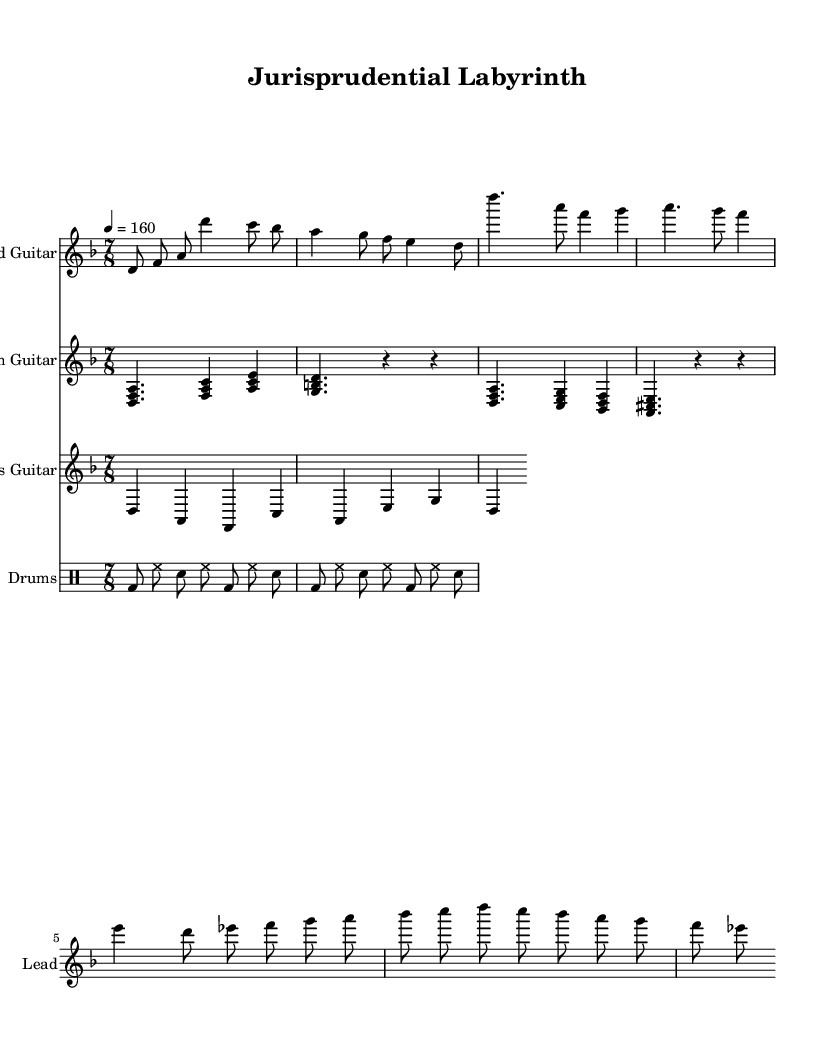What is the key signature of this music? The key signature is D minor, which contains one flat (B flat). This can be determined by looking at the key signature indicated at the beginning of the score, which reveals the presence of one flat.
Answer: D minor What is the time signature of this music? The time signature is seven eight, as we can see in the beginning of the score where the time signature is displayed. This shows there are seven eighth notes per measure.
Answer: Seven eight What is the tempo marking of this piece? The tempo marking is quarter note equals 160, which outlines the speed of the music. It can be found in the marking at the beginning of the score demonstrating the beats per minute.
Answer: 160 How many measures are in the lead guitar part? There are eight measures in the lead guitar part, which can be counted by looking through the various segments of the lead guitar line and noting the divisions between each measure.
Answer: Eight Which scale is used in the simplified guitar solo? The simplified guitar solo uses a D Phrygian dominant scale. This is identified by analyzing the notes in the solo section, which correspond to the notes of the D Phrygian dominant scale.
Answer: D Phrygian dominant What is the rhythmic pattern for the drums in the music? The rhythmic pattern for the drums consists of a basic rock beat in seven eight. This is concluded by studying the drum notation, which indicates a repeating pattern typical for a rock genre played in the 7/8 time signature.
Answer: Basic rock beat in seven eight What instruments are featured in this score? The featured instruments are lead guitar, rhythm guitar, bass guitar, and drums. This is discerned by reading the staff labels at the beginning of each part in the score, which clearly list the instruments used.
Answer: Lead guitar, rhythm guitar, bass guitar, drums 